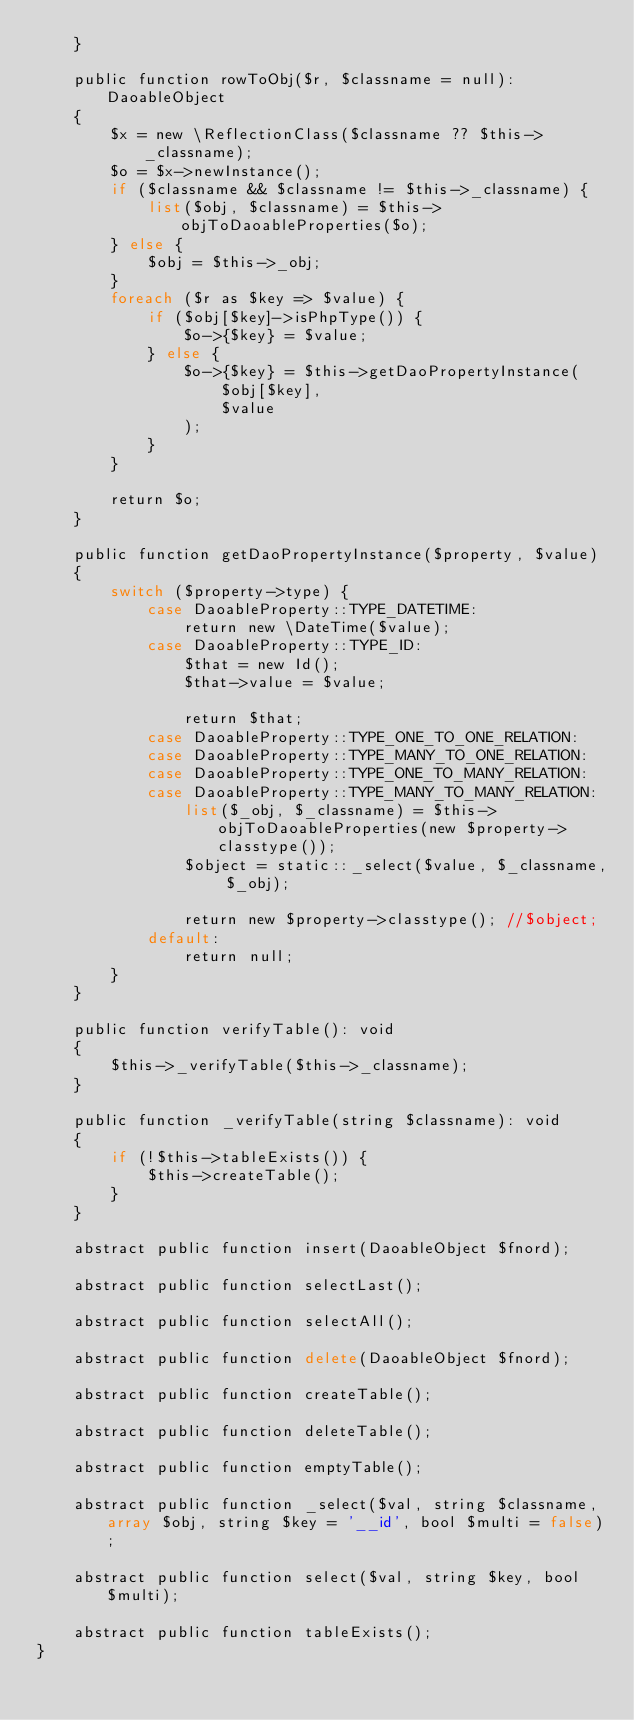Convert code to text. <code><loc_0><loc_0><loc_500><loc_500><_PHP_>    }

    public function rowToObj($r, $classname = null): DaoableObject
    {
        $x = new \ReflectionClass($classname ?? $this->_classname);
        $o = $x->newInstance();
        if ($classname && $classname != $this->_classname) {
            list($obj, $classname) = $this->objToDaoableProperties($o);
        } else {
            $obj = $this->_obj;
        }
        foreach ($r as $key => $value) {
            if ($obj[$key]->isPhpType()) {
                $o->{$key} = $value;
            } else {
                $o->{$key} = $this->getDaoPropertyInstance(
                    $obj[$key],
                    $value
                );
            }
        }

        return $o;
    }

    public function getDaoPropertyInstance($property, $value)
    {
        switch ($property->type) {
            case DaoableProperty::TYPE_DATETIME:
                return new \DateTime($value);
            case DaoableProperty::TYPE_ID:
                $that = new Id();
                $that->value = $value;

                return $that;
            case DaoableProperty::TYPE_ONE_TO_ONE_RELATION:
            case DaoableProperty::TYPE_MANY_TO_ONE_RELATION:
            case DaoableProperty::TYPE_ONE_TO_MANY_RELATION:
            case DaoableProperty::TYPE_MANY_TO_MANY_RELATION:
                list($_obj, $_classname) = $this->objToDaoableProperties(new $property->classtype());
                $object = static::_select($value, $_classname, $_obj);

                return new $property->classtype(); //$object;
            default:
                return null;
        }
    }

    public function verifyTable(): void
    {
        $this->_verifyTable($this->_classname);
    }

    public function _verifyTable(string $classname): void
    {
        if (!$this->tableExists()) {
            $this->createTable();
        }
    }

    abstract public function insert(DaoableObject $fnord);

    abstract public function selectLast();

    abstract public function selectAll();

    abstract public function delete(DaoableObject $fnord);

    abstract public function createTable();

    abstract public function deleteTable();

    abstract public function emptyTable();

    abstract public function _select($val, string $classname, array $obj, string $key = '__id', bool $multi = false);

    abstract public function select($val, string $key, bool $multi);

    abstract public function tableExists();
}
</code> 